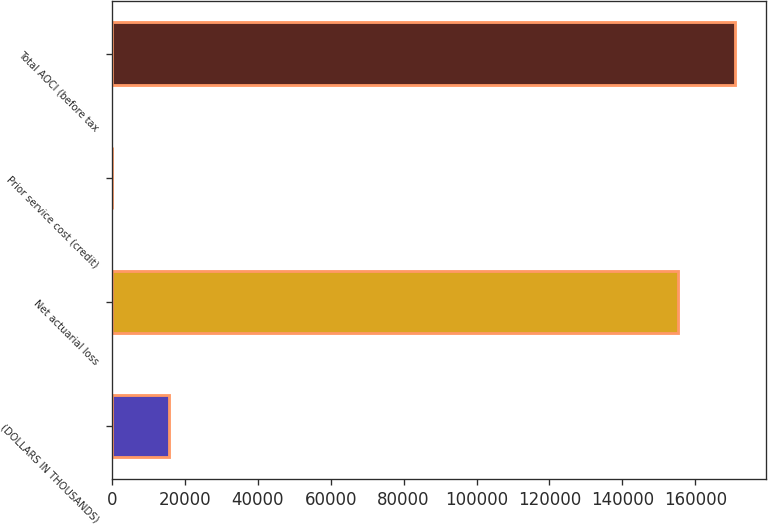<chart> <loc_0><loc_0><loc_500><loc_500><bar_chart><fcel>(DOLLARS IN THOUSANDS)<fcel>Net actuarial loss<fcel>Prior service cost (credit)<fcel>Total AOCI (before tax<nl><fcel>15547.5<fcel>155305<fcel>17<fcel>170836<nl></chart> 